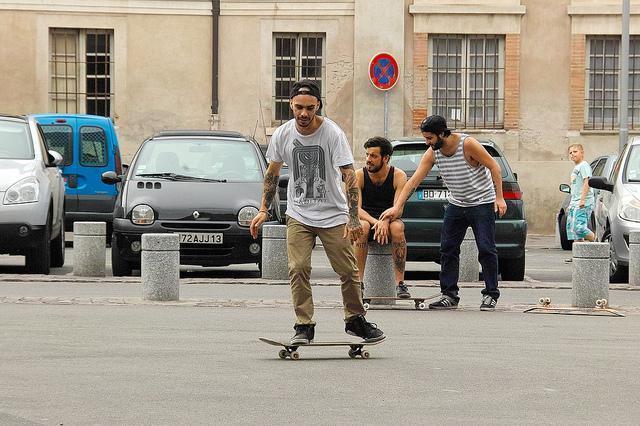How many people in the picture?
Give a very brief answer. 4. How many of these people are riding skateboards?
Give a very brief answer. 1. How many cars are there?
Give a very brief answer. 4. How many people are in the photo?
Give a very brief answer. 4. How many clocks can you see?
Give a very brief answer. 0. 